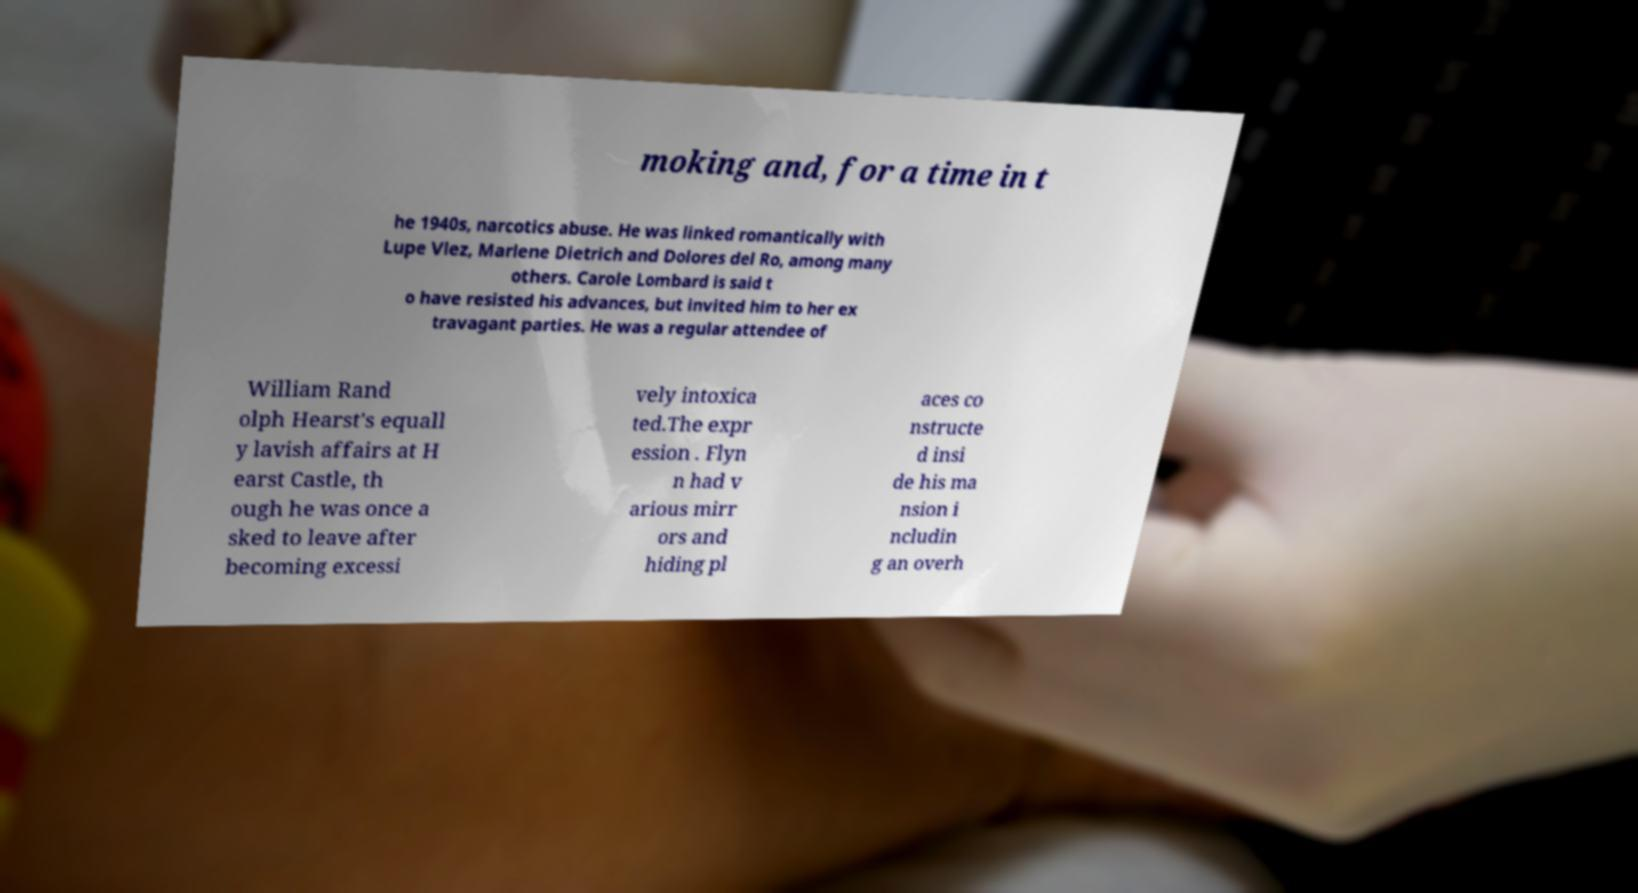There's text embedded in this image that I need extracted. Can you transcribe it verbatim? moking and, for a time in t he 1940s, narcotics abuse. He was linked romantically with Lupe Vlez, Marlene Dietrich and Dolores del Ro, among many others. Carole Lombard is said t o have resisted his advances, but invited him to her ex travagant parties. He was a regular attendee of William Rand olph Hearst's equall y lavish affairs at H earst Castle, th ough he was once a sked to leave after becoming excessi vely intoxica ted.The expr ession . Flyn n had v arious mirr ors and hiding pl aces co nstructe d insi de his ma nsion i ncludin g an overh 